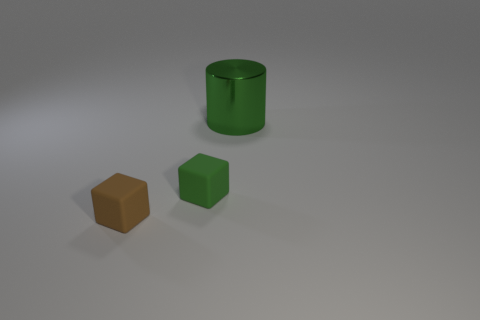Subtract all blocks. How many objects are left? 1 Subtract all gray spheres. How many gray blocks are left? 0 Subtract all big blue rubber objects. Subtract all green cylinders. How many objects are left? 2 Add 3 green rubber cubes. How many green rubber cubes are left? 4 Add 1 rubber things. How many rubber things exist? 3 Add 1 purple spheres. How many objects exist? 4 Subtract 1 green blocks. How many objects are left? 2 Subtract 1 cubes. How many cubes are left? 1 Subtract all yellow cylinders. Subtract all green cubes. How many cylinders are left? 1 